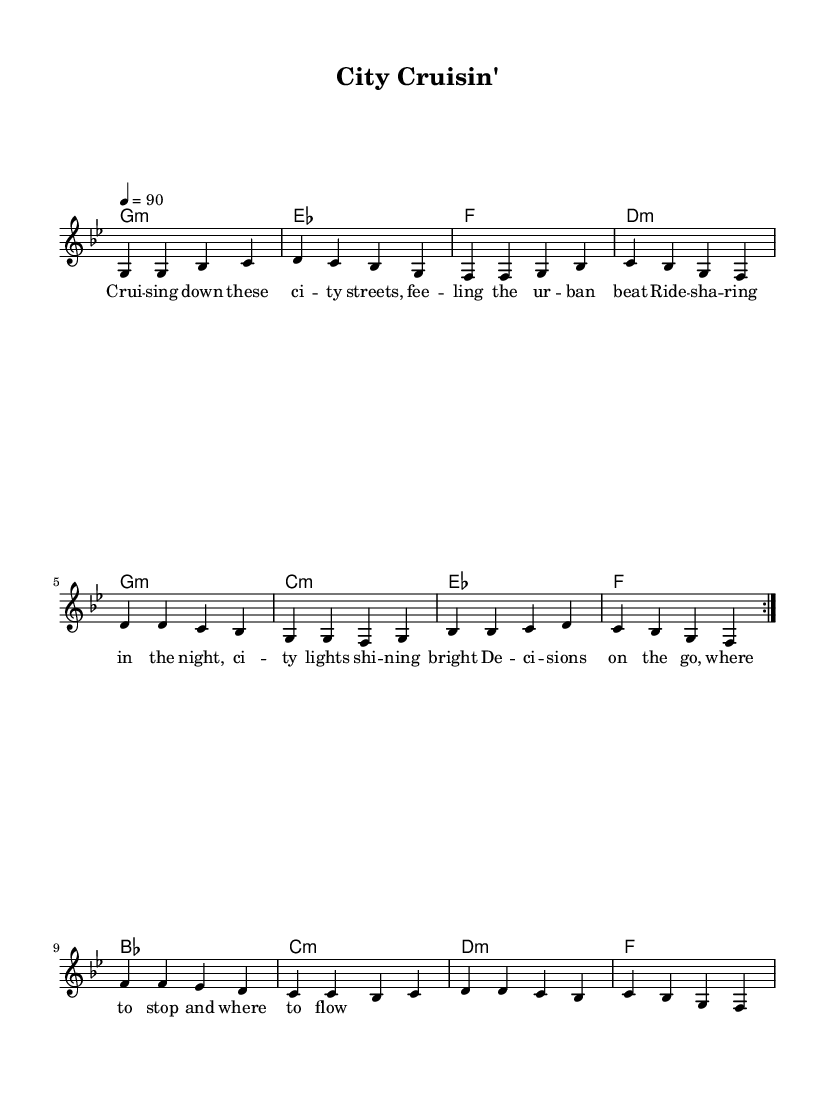What is the key signature of this music? The key signature is G minor, which has two flats (B flat and E flat).
Answer: G minor What is the time signature of the piece? The time signature is indicated by the notation at the beginning, where it shows a 4 over a 4, meaning there are four beats per measure.
Answer: 4/4 What is the tempo marking for this piece? The tempo is indicated at the start, specifying that the piece should be played at 90 beats per minute.
Answer: 90 How many measures are there in the melody section? By counting the groups separated by vertical lines, there are a total of 12 measures in the melody section.
Answer: 12 Which chord appears at the beginning of the harmony section? The first chord written at the beginning of the harmony section is G minor, as noted by the chord symbol.
Answer: G minor Describe the overall theme reflected in the lyrics. The lyrics reflect urban life and decisions made while ride-sharing in a city, encapsulating the vibrant experience of city living.
Answer: Urban transportation What is the last note of the melody? The last note of the melody is F, which is the note played just before the end of the phrase.
Answer: F 